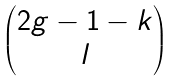Convert formula to latex. <formula><loc_0><loc_0><loc_500><loc_500>\begin{pmatrix} 2 g - 1 - k \\ l \end{pmatrix}</formula> 